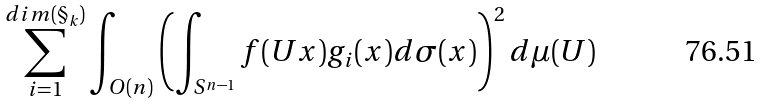<formula> <loc_0><loc_0><loc_500><loc_500>\sum _ { i = 1 } ^ { d i m ( \S _ { k } ) } \int _ { O ( n ) } \left ( \int _ { S ^ { n - 1 } } f ( U x ) g _ { i } ( x ) d \sigma ( x ) \right ) ^ { 2 } d \mu ( U )</formula> 